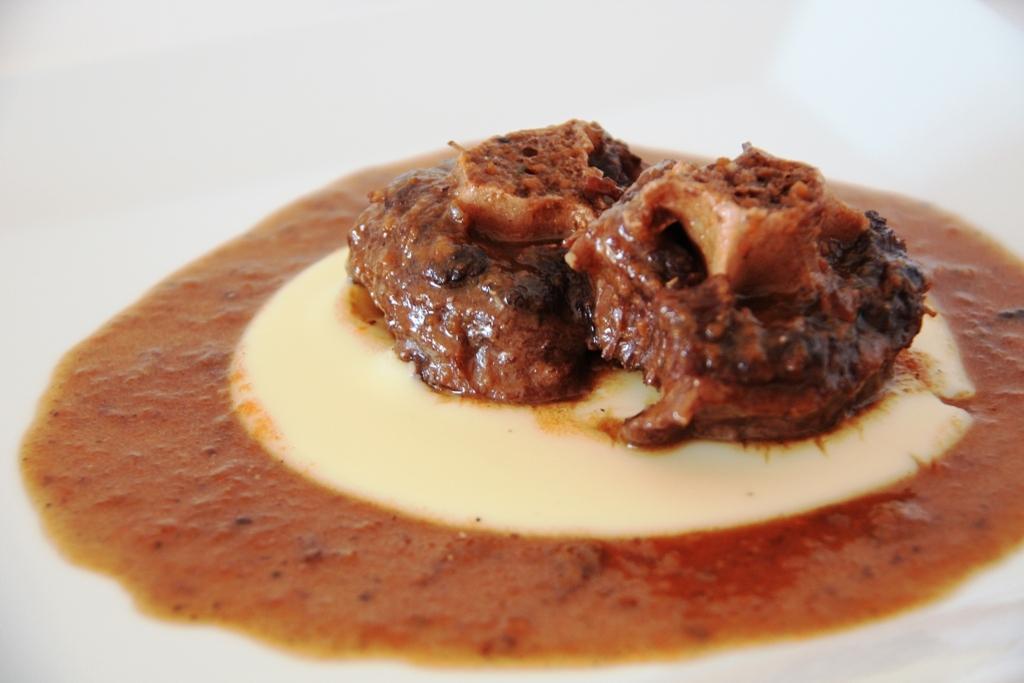How would you summarize this image in a sentence or two? In this picture I can see the food item. 